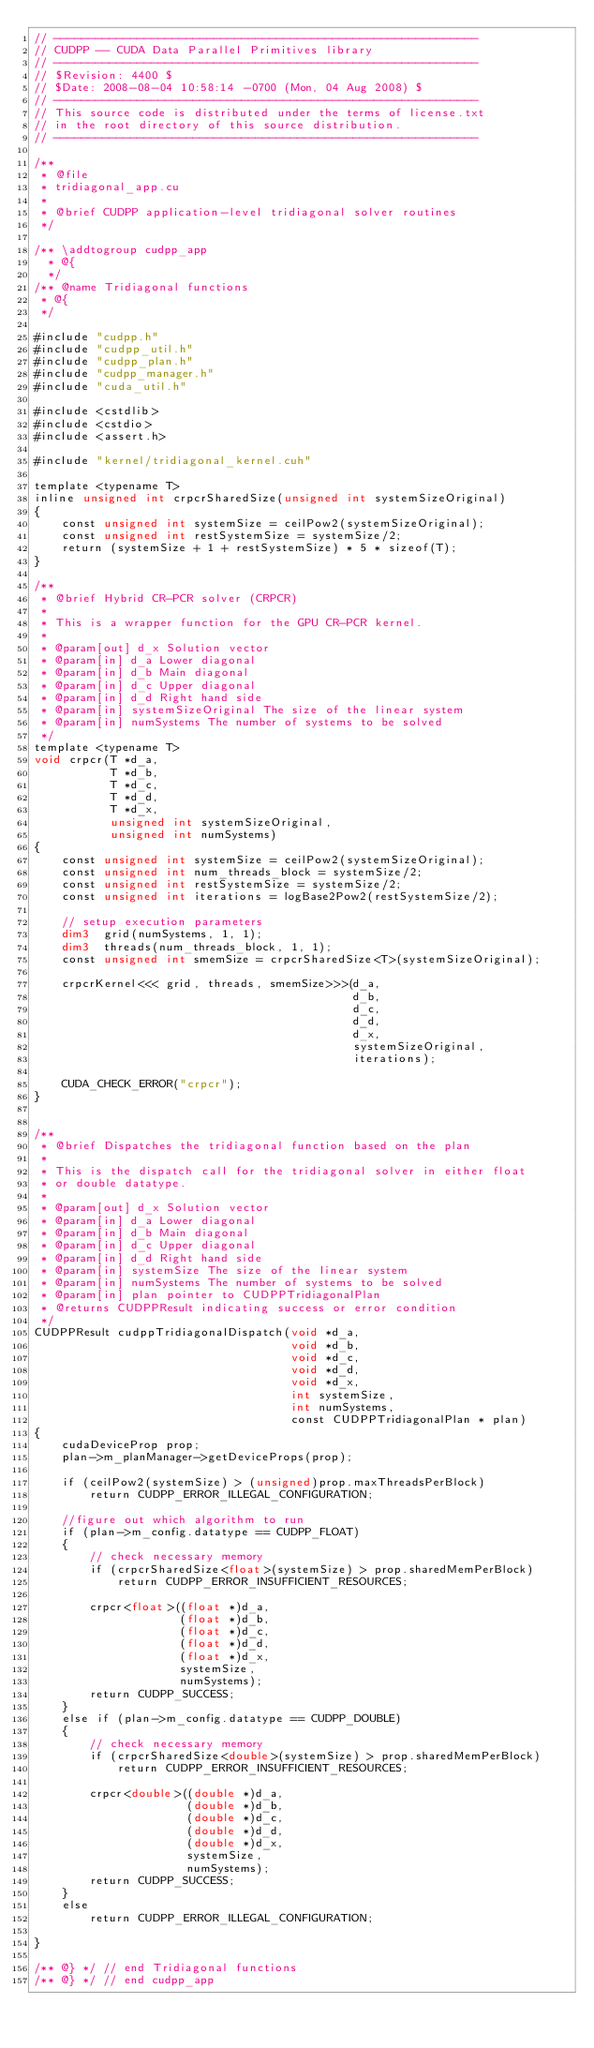<code> <loc_0><loc_0><loc_500><loc_500><_Cuda_>// -------------------------------------------------------------
// CUDPP -- CUDA Data Parallel Primitives library
// -------------------------------------------------------------
// $Revision: 4400 $
// $Date: 2008-08-04 10:58:14 -0700 (Mon, 04 Aug 2008) $
// ------------------------------------------------------------- 
// This source code is distributed under the terms of license.txt 
// in the root directory of this source distribution.
// ------------------------------------------------------------- 

/**
 * @file
 * tridiagonal_app.cu
 *
 * @brief CUDPP application-level tridiagonal solver routines
 */

/** \addtogroup cudpp_app
  * @{
  */
/** @name Tridiagonal functions
 * @{
 */

#include "cudpp.h"
#include "cudpp_util.h"
#include "cudpp_plan.h"
#include "cudpp_manager.h"
#include "cuda_util.h"

#include <cstdlib>
#include <cstdio>
#include <assert.h>

#include "kernel/tridiagonal_kernel.cuh"

template <typename T>
inline unsigned int crpcrSharedSize(unsigned int systemSizeOriginal)
{
    const unsigned int systemSize = ceilPow2(systemSizeOriginal);
    const unsigned int restSystemSize = systemSize/2;
    return (systemSize + 1 + restSystemSize) * 5 * sizeof(T);
}

/**
 * @brief Hybrid CR-PCR solver (CRPCR)
 *
 * This is a wrapper function for the GPU CR-PCR kernel.
 *
 * @param[out] d_x Solution vector
 * @param[in] d_a Lower diagonal
 * @param[in] d_b Main diagonal
 * @param[in] d_c Upper diagonal
 * @param[in] d_d Right hand side
 * @param[in] systemSizeOriginal The size of the linear system
 * @param[in] numSystems The number of systems to be solved
 */
template <typename T>
void crpcr(T *d_a, 
           T *d_b, 
           T *d_c, 
           T *d_d, 
           T *d_x, 
           unsigned int systemSizeOriginal, 
           unsigned int numSystems)
{
    const unsigned int systemSize = ceilPow2(systemSizeOriginal);
    const unsigned int num_threads_block = systemSize/2;
    const unsigned int restSystemSize = systemSize/2;
    const unsigned int iterations = logBase2Pow2(restSystemSize/2);
  
    // setup execution parameters
    dim3  grid(numSystems, 1, 1);
    dim3  threads(num_threads_block, 1, 1);
    const unsigned int smemSize = crpcrSharedSize<T>(systemSizeOriginal);

    crpcrKernel<<< grid, threads, smemSize>>>(d_a, 
                                              d_b, 
                                              d_c, 
                                              d_d, 
                                              d_x, 
                                              systemSizeOriginal,
                                              iterations);

    CUDA_CHECK_ERROR("crpcr");
}


/**
 * @brief Dispatches the tridiagonal function based on the plan
 *
 * This is the dispatch call for the tridiagonal solver in either float 
 * or double datatype. 
 *
 * @param[out] d_x Solution vector
 * @param[in] d_a Lower diagonal
 * @param[in] d_b Main diagonal
 * @param[in] d_c Upper diagonal
 * @param[in] d_d Right hand side
 * @param[in] systemSize The size of the linear system
 * @param[in] numSystems The number of systems to be solved
 * @param[in] plan pointer to CUDPPTridiagonalPlan
 * @returns CUDPPResult indicating success or error condition
 */
CUDPPResult cudppTridiagonalDispatch(void *d_a, 
                                     void *d_b, 
                                     void *d_c, 
                                     void *d_d, 
                                     void *d_x, 
                                     int systemSize, 
                                     int numSystems, 
                                     const CUDPPTridiagonalPlan * plan)
{
    cudaDeviceProp prop;
    plan->m_planManager->getDeviceProps(prop);

    if (ceilPow2(systemSize) > (unsigned)prop.maxThreadsPerBlock)
        return CUDPP_ERROR_ILLEGAL_CONFIGURATION;

    //figure out which algorithm to run
    if (plan->m_config.datatype == CUDPP_FLOAT)
    {
        // check necessary memory
        if (crpcrSharedSize<float>(systemSize) > prop.sharedMemPerBlock)
            return CUDPP_ERROR_INSUFFICIENT_RESOURCES;

        crpcr<float>((float *)d_a, 
                     (float *)d_b, 
                     (float *)d_c, 
                     (float *)d_d, 
                     (float *)d_x, 
                     systemSize, 
                     numSystems);
        return CUDPP_SUCCESS;
    }
    else if (plan->m_config.datatype == CUDPP_DOUBLE)
    {
        // check necessary memory
        if (crpcrSharedSize<double>(systemSize) > prop.sharedMemPerBlock)
            return CUDPP_ERROR_INSUFFICIENT_RESOURCES;

        crpcr<double>((double *)d_a, 
                      (double *)d_b, 
                      (double *)d_c, 
                      (double *)d_d, 
                      (double *)d_x, 
                      systemSize, 
                      numSystems);
        return CUDPP_SUCCESS;
    }
    else
        return CUDPP_ERROR_ILLEGAL_CONFIGURATION;
    
}

/** @} */ // end Tridiagonal functions
/** @} */ // end cudpp_app
</code> 